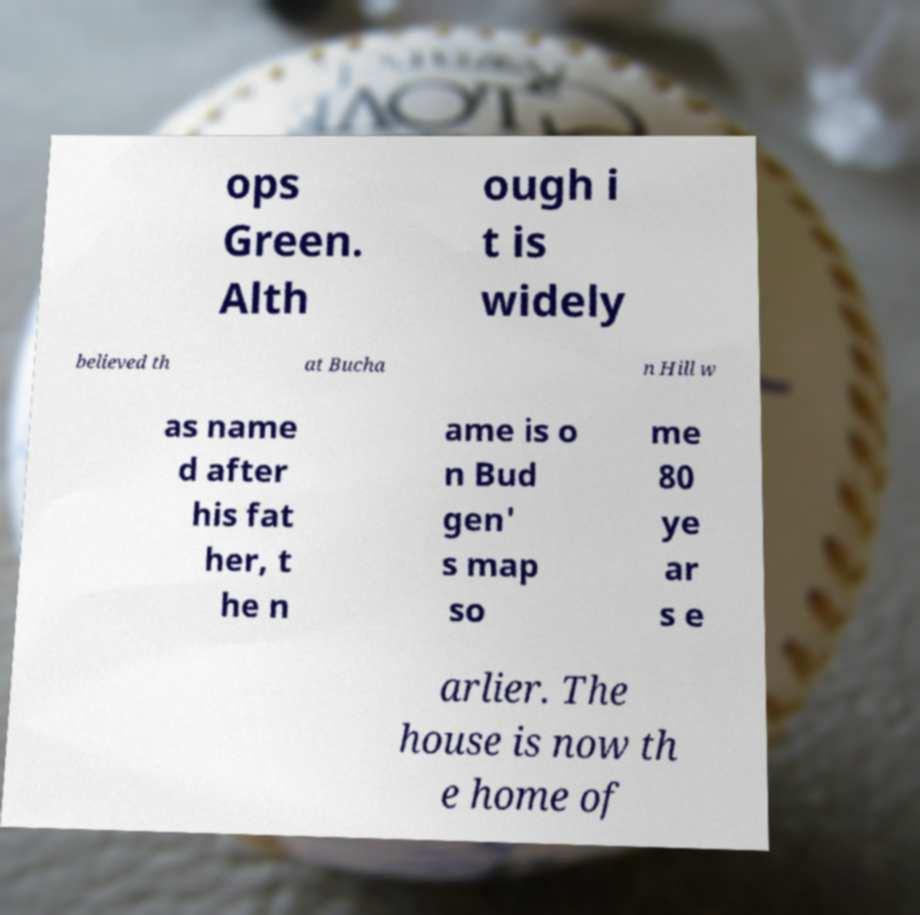Please read and relay the text visible in this image. What does it say? ops Green. Alth ough i t is widely believed th at Bucha n Hill w as name d after his fat her, t he n ame is o n Bud gen' s map so me 80 ye ar s e arlier. The house is now th e home of 